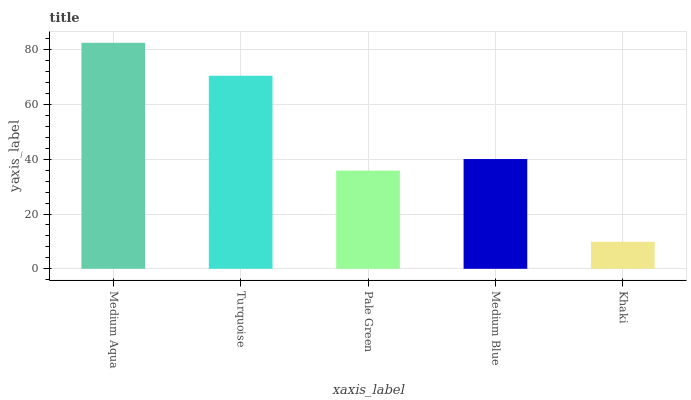Is Khaki the minimum?
Answer yes or no. Yes. Is Medium Aqua the maximum?
Answer yes or no. Yes. Is Turquoise the minimum?
Answer yes or no. No. Is Turquoise the maximum?
Answer yes or no. No. Is Medium Aqua greater than Turquoise?
Answer yes or no. Yes. Is Turquoise less than Medium Aqua?
Answer yes or no. Yes. Is Turquoise greater than Medium Aqua?
Answer yes or no. No. Is Medium Aqua less than Turquoise?
Answer yes or no. No. Is Medium Blue the high median?
Answer yes or no. Yes. Is Medium Blue the low median?
Answer yes or no. Yes. Is Pale Green the high median?
Answer yes or no. No. Is Turquoise the low median?
Answer yes or no. No. 